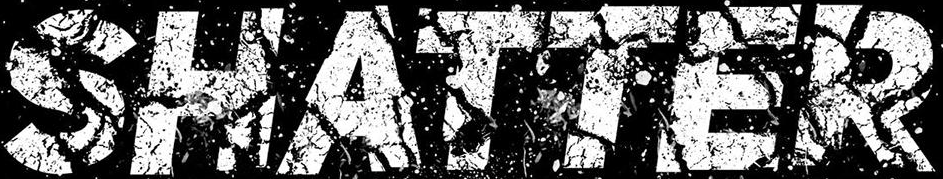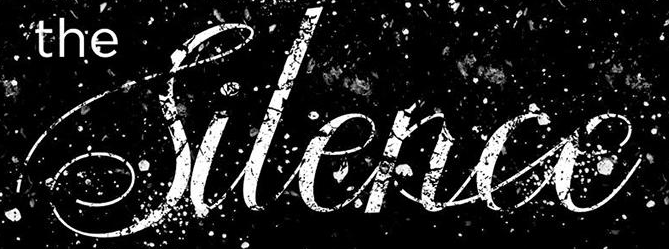Identify the words shown in these images in order, separated by a semicolon. SHATTER; Silence 